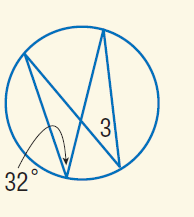Answer the mathemtical geometry problem and directly provide the correct option letter.
Question: Find m \angle 3.
Choices: A: 32 B: 64 C: 128 D: 148 A 